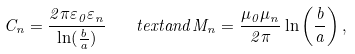<formula> <loc_0><loc_0><loc_500><loc_500>C _ { n } = \frac { 2 \pi \varepsilon _ { 0 } \varepsilon _ { n } } { \ln ( \frac { b } { a } ) } \, \ \ \ t e x t { a n d } M _ { n } = \frac { \mu _ { 0 } \mu _ { n } } { 2 \pi } \ln \left ( \frac { b } { a } \right ) , \,</formula> 